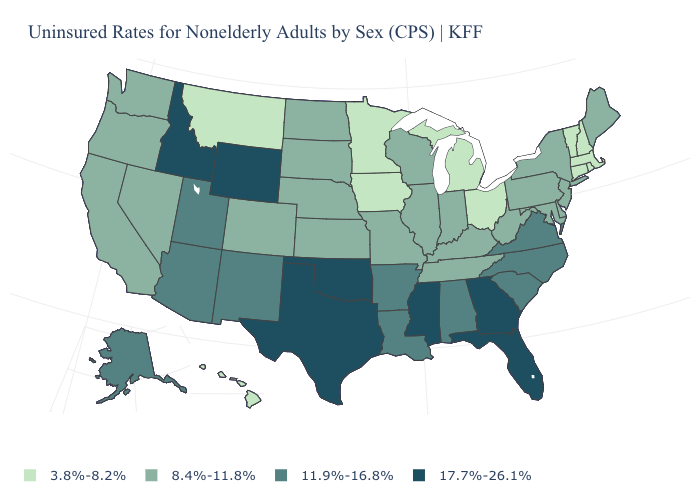What is the value of West Virginia?
Short answer required. 8.4%-11.8%. Name the states that have a value in the range 11.9%-16.8%?
Give a very brief answer. Alabama, Alaska, Arizona, Arkansas, Louisiana, New Mexico, North Carolina, South Carolina, Utah, Virginia. Name the states that have a value in the range 8.4%-11.8%?
Write a very short answer. California, Colorado, Delaware, Illinois, Indiana, Kansas, Kentucky, Maine, Maryland, Missouri, Nebraska, Nevada, New Jersey, New York, North Dakota, Oregon, Pennsylvania, South Dakota, Tennessee, Washington, West Virginia, Wisconsin. Name the states that have a value in the range 3.8%-8.2%?
Quick response, please. Connecticut, Hawaii, Iowa, Massachusetts, Michigan, Minnesota, Montana, New Hampshire, Ohio, Rhode Island, Vermont. Does New Hampshire have the lowest value in the USA?
Give a very brief answer. Yes. What is the highest value in the USA?
Write a very short answer. 17.7%-26.1%. Among the states that border Iowa , does Wisconsin have the lowest value?
Quick response, please. No. What is the value of Wisconsin?
Quick response, please. 8.4%-11.8%. What is the value of Wyoming?
Quick response, please. 17.7%-26.1%. What is the lowest value in the USA?
Be succinct. 3.8%-8.2%. What is the value of Indiana?
Short answer required. 8.4%-11.8%. What is the value of Pennsylvania?
Be succinct. 8.4%-11.8%. Does the first symbol in the legend represent the smallest category?
Write a very short answer. Yes. Name the states that have a value in the range 8.4%-11.8%?
Concise answer only. California, Colorado, Delaware, Illinois, Indiana, Kansas, Kentucky, Maine, Maryland, Missouri, Nebraska, Nevada, New Jersey, New York, North Dakota, Oregon, Pennsylvania, South Dakota, Tennessee, Washington, West Virginia, Wisconsin. What is the value of Idaho?
Give a very brief answer. 17.7%-26.1%. 